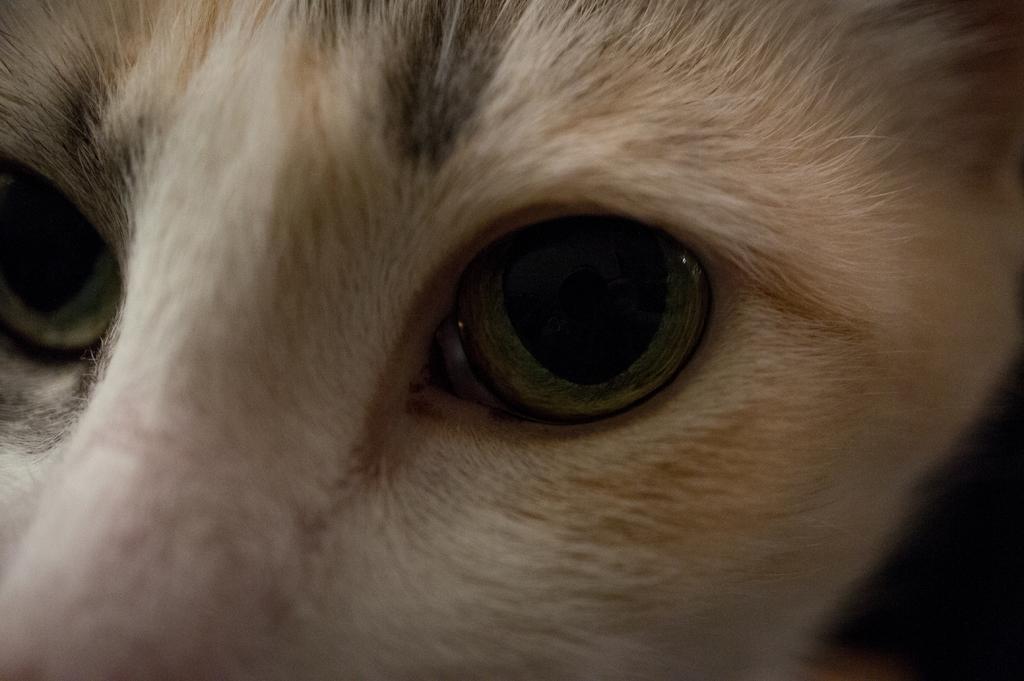Please provide a concise description of this image. In this picture we can see an animal face and eyes. 